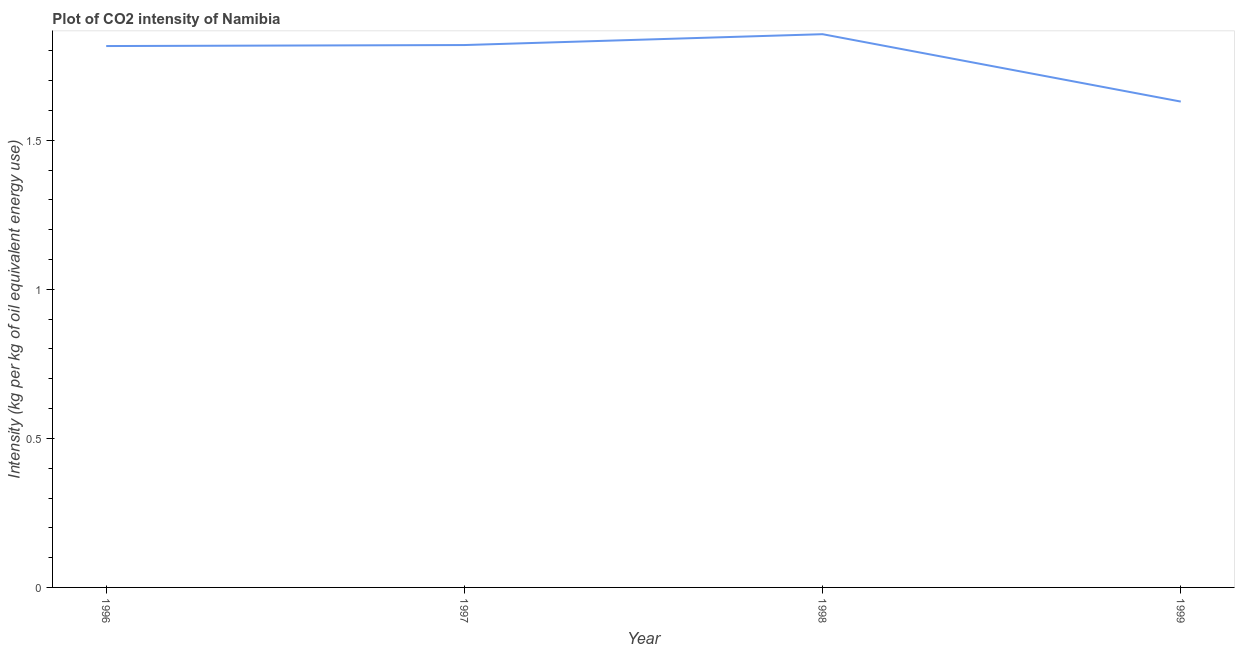What is the co2 intensity in 1996?
Offer a terse response. 1.82. Across all years, what is the maximum co2 intensity?
Make the answer very short. 1.86. Across all years, what is the minimum co2 intensity?
Provide a succinct answer. 1.63. In which year was the co2 intensity minimum?
Give a very brief answer. 1999. What is the sum of the co2 intensity?
Keep it short and to the point. 7.12. What is the difference between the co2 intensity in 1997 and 1998?
Your response must be concise. -0.04. What is the average co2 intensity per year?
Ensure brevity in your answer.  1.78. What is the median co2 intensity?
Ensure brevity in your answer.  1.82. What is the ratio of the co2 intensity in 1996 to that in 1997?
Give a very brief answer. 1. Is the co2 intensity in 1996 less than that in 1997?
Offer a terse response. Yes. Is the difference between the co2 intensity in 1998 and 1999 greater than the difference between any two years?
Offer a very short reply. Yes. What is the difference between the highest and the second highest co2 intensity?
Give a very brief answer. 0.04. What is the difference between the highest and the lowest co2 intensity?
Give a very brief answer. 0.23. How many lines are there?
Give a very brief answer. 1. How many years are there in the graph?
Make the answer very short. 4. Does the graph contain grids?
Offer a very short reply. No. What is the title of the graph?
Your answer should be compact. Plot of CO2 intensity of Namibia. What is the label or title of the Y-axis?
Provide a short and direct response. Intensity (kg per kg of oil equivalent energy use). What is the Intensity (kg per kg of oil equivalent energy use) of 1996?
Ensure brevity in your answer.  1.82. What is the Intensity (kg per kg of oil equivalent energy use) in 1997?
Provide a succinct answer. 1.82. What is the Intensity (kg per kg of oil equivalent energy use) in 1998?
Provide a succinct answer. 1.86. What is the Intensity (kg per kg of oil equivalent energy use) of 1999?
Provide a succinct answer. 1.63. What is the difference between the Intensity (kg per kg of oil equivalent energy use) in 1996 and 1997?
Keep it short and to the point. -0. What is the difference between the Intensity (kg per kg of oil equivalent energy use) in 1996 and 1998?
Give a very brief answer. -0.04. What is the difference between the Intensity (kg per kg of oil equivalent energy use) in 1996 and 1999?
Keep it short and to the point. 0.19. What is the difference between the Intensity (kg per kg of oil equivalent energy use) in 1997 and 1998?
Give a very brief answer. -0.04. What is the difference between the Intensity (kg per kg of oil equivalent energy use) in 1997 and 1999?
Offer a terse response. 0.19. What is the difference between the Intensity (kg per kg of oil equivalent energy use) in 1998 and 1999?
Offer a terse response. 0.23. What is the ratio of the Intensity (kg per kg of oil equivalent energy use) in 1996 to that in 1999?
Your answer should be compact. 1.11. What is the ratio of the Intensity (kg per kg of oil equivalent energy use) in 1997 to that in 1998?
Provide a short and direct response. 0.98. What is the ratio of the Intensity (kg per kg of oil equivalent energy use) in 1997 to that in 1999?
Make the answer very short. 1.12. What is the ratio of the Intensity (kg per kg of oil equivalent energy use) in 1998 to that in 1999?
Provide a succinct answer. 1.14. 